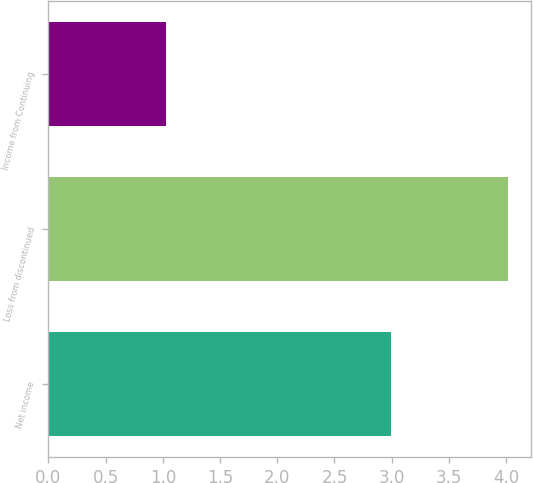<chart> <loc_0><loc_0><loc_500><loc_500><bar_chart><fcel>Net income<fcel>Loss from discontinued<fcel>Income from Continuing<nl><fcel>2.99<fcel>4.02<fcel>1.03<nl></chart> 